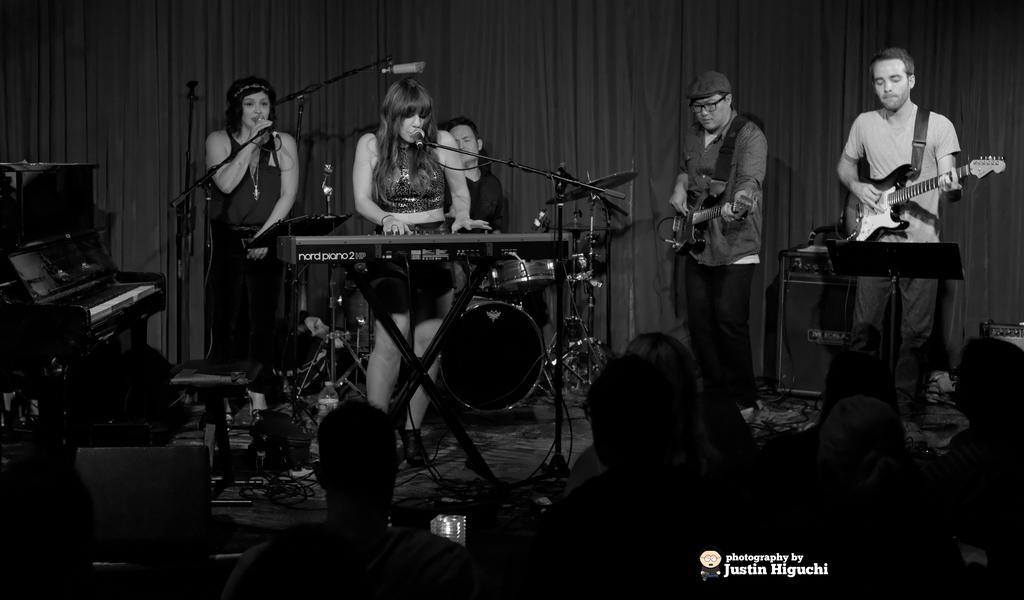Could you give a brief overview of what you see in this image? This is black and white picture. Here we can see some persons standing on the floor. And she is singing on the mike. Here we can see two persons playing guitars. On the background we can see a curtain. And this is piano. 